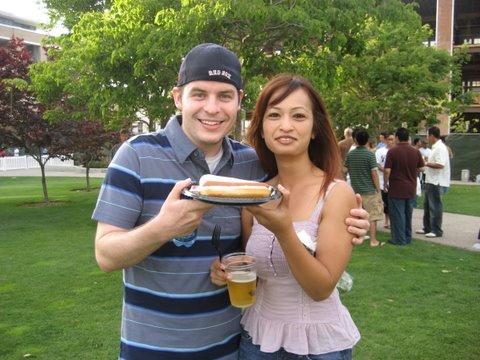What does the man have his arm around?
Concise answer only. Woman. What are the people holding?
Write a very short answer. Hot dog. Do the plan on sharing?
Concise answer only. Yes. What do they have to drink?
Quick response, please. Beer. 